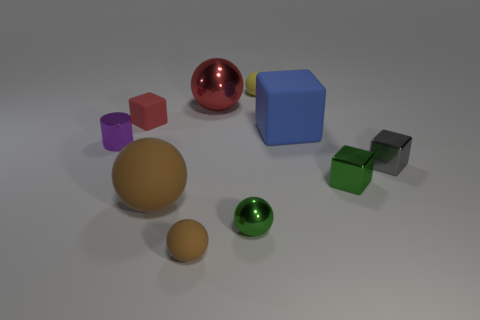Subtract all small green metal balls. How many balls are left? 4 Subtract all green blocks. How many blocks are left? 3 Subtract all cylinders. How many objects are left? 9 Add 10 big green matte things. How many big green matte things exist? 10 Subtract 1 red balls. How many objects are left? 9 Subtract 4 spheres. How many spheres are left? 1 Subtract all red blocks. Subtract all purple balls. How many blocks are left? 3 Subtract all blue blocks. How many red balls are left? 1 Subtract all yellow matte spheres. Subtract all purple things. How many objects are left? 8 Add 7 red shiny balls. How many red shiny balls are left? 8 